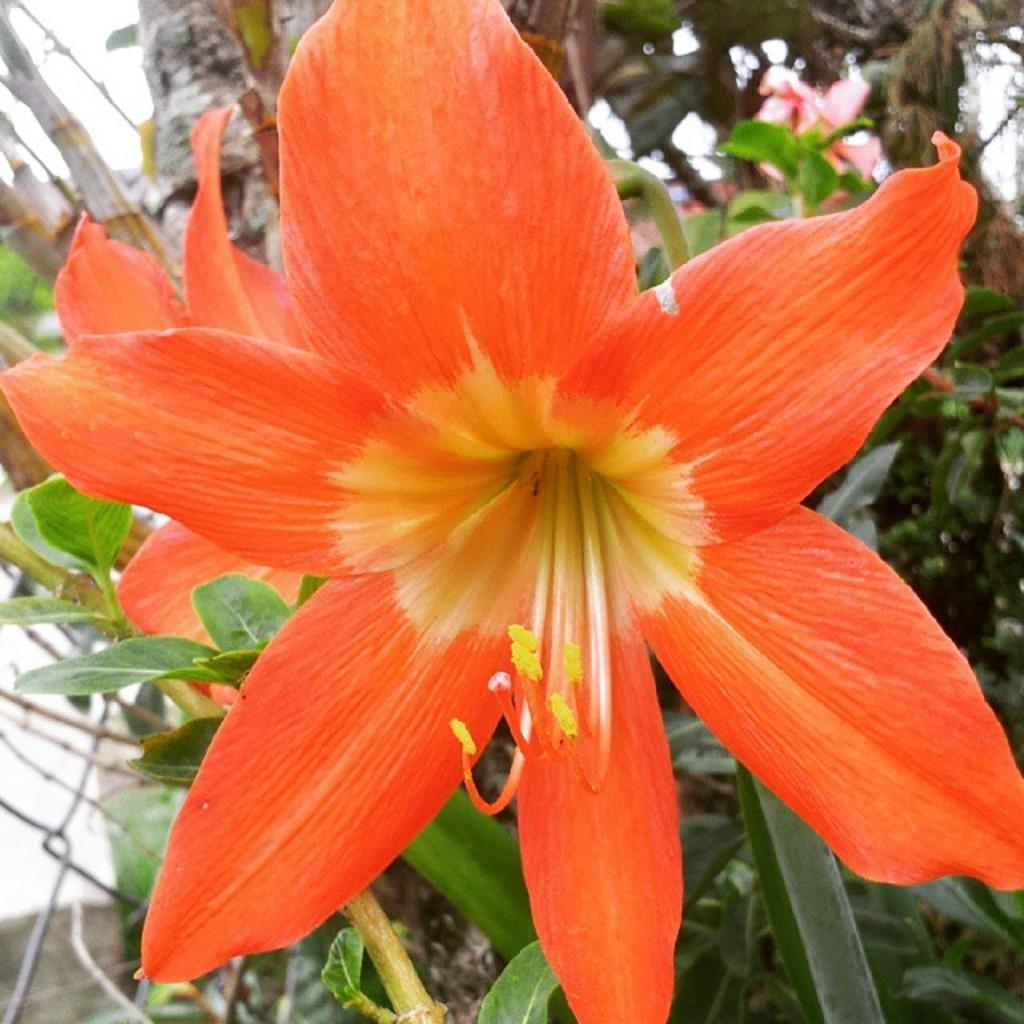What type of flora can be seen in the image? There are flowers and plants in the image. What is present in the background of the image? There is a mesh and a tree trunk visible in the background of the image. What is the range of the friction between the flowers and the tree trunk in the image? There is no information about friction or range between the flowers and the tree trunk in the image, as it focuses on the visual appearance of the flora and background elements. 